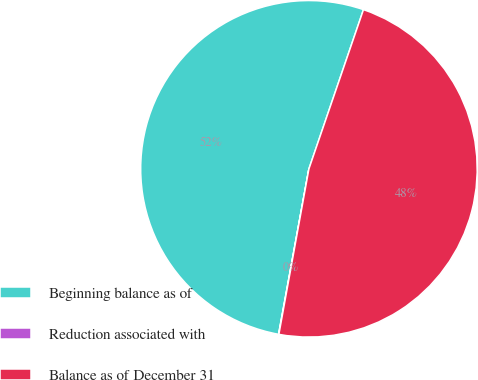Convert chart to OTSL. <chart><loc_0><loc_0><loc_500><loc_500><pie_chart><fcel>Beginning balance as of<fcel>Reduction associated with<fcel>Balance as of December 31<nl><fcel>52.36%<fcel>0.03%<fcel>47.6%<nl></chart> 